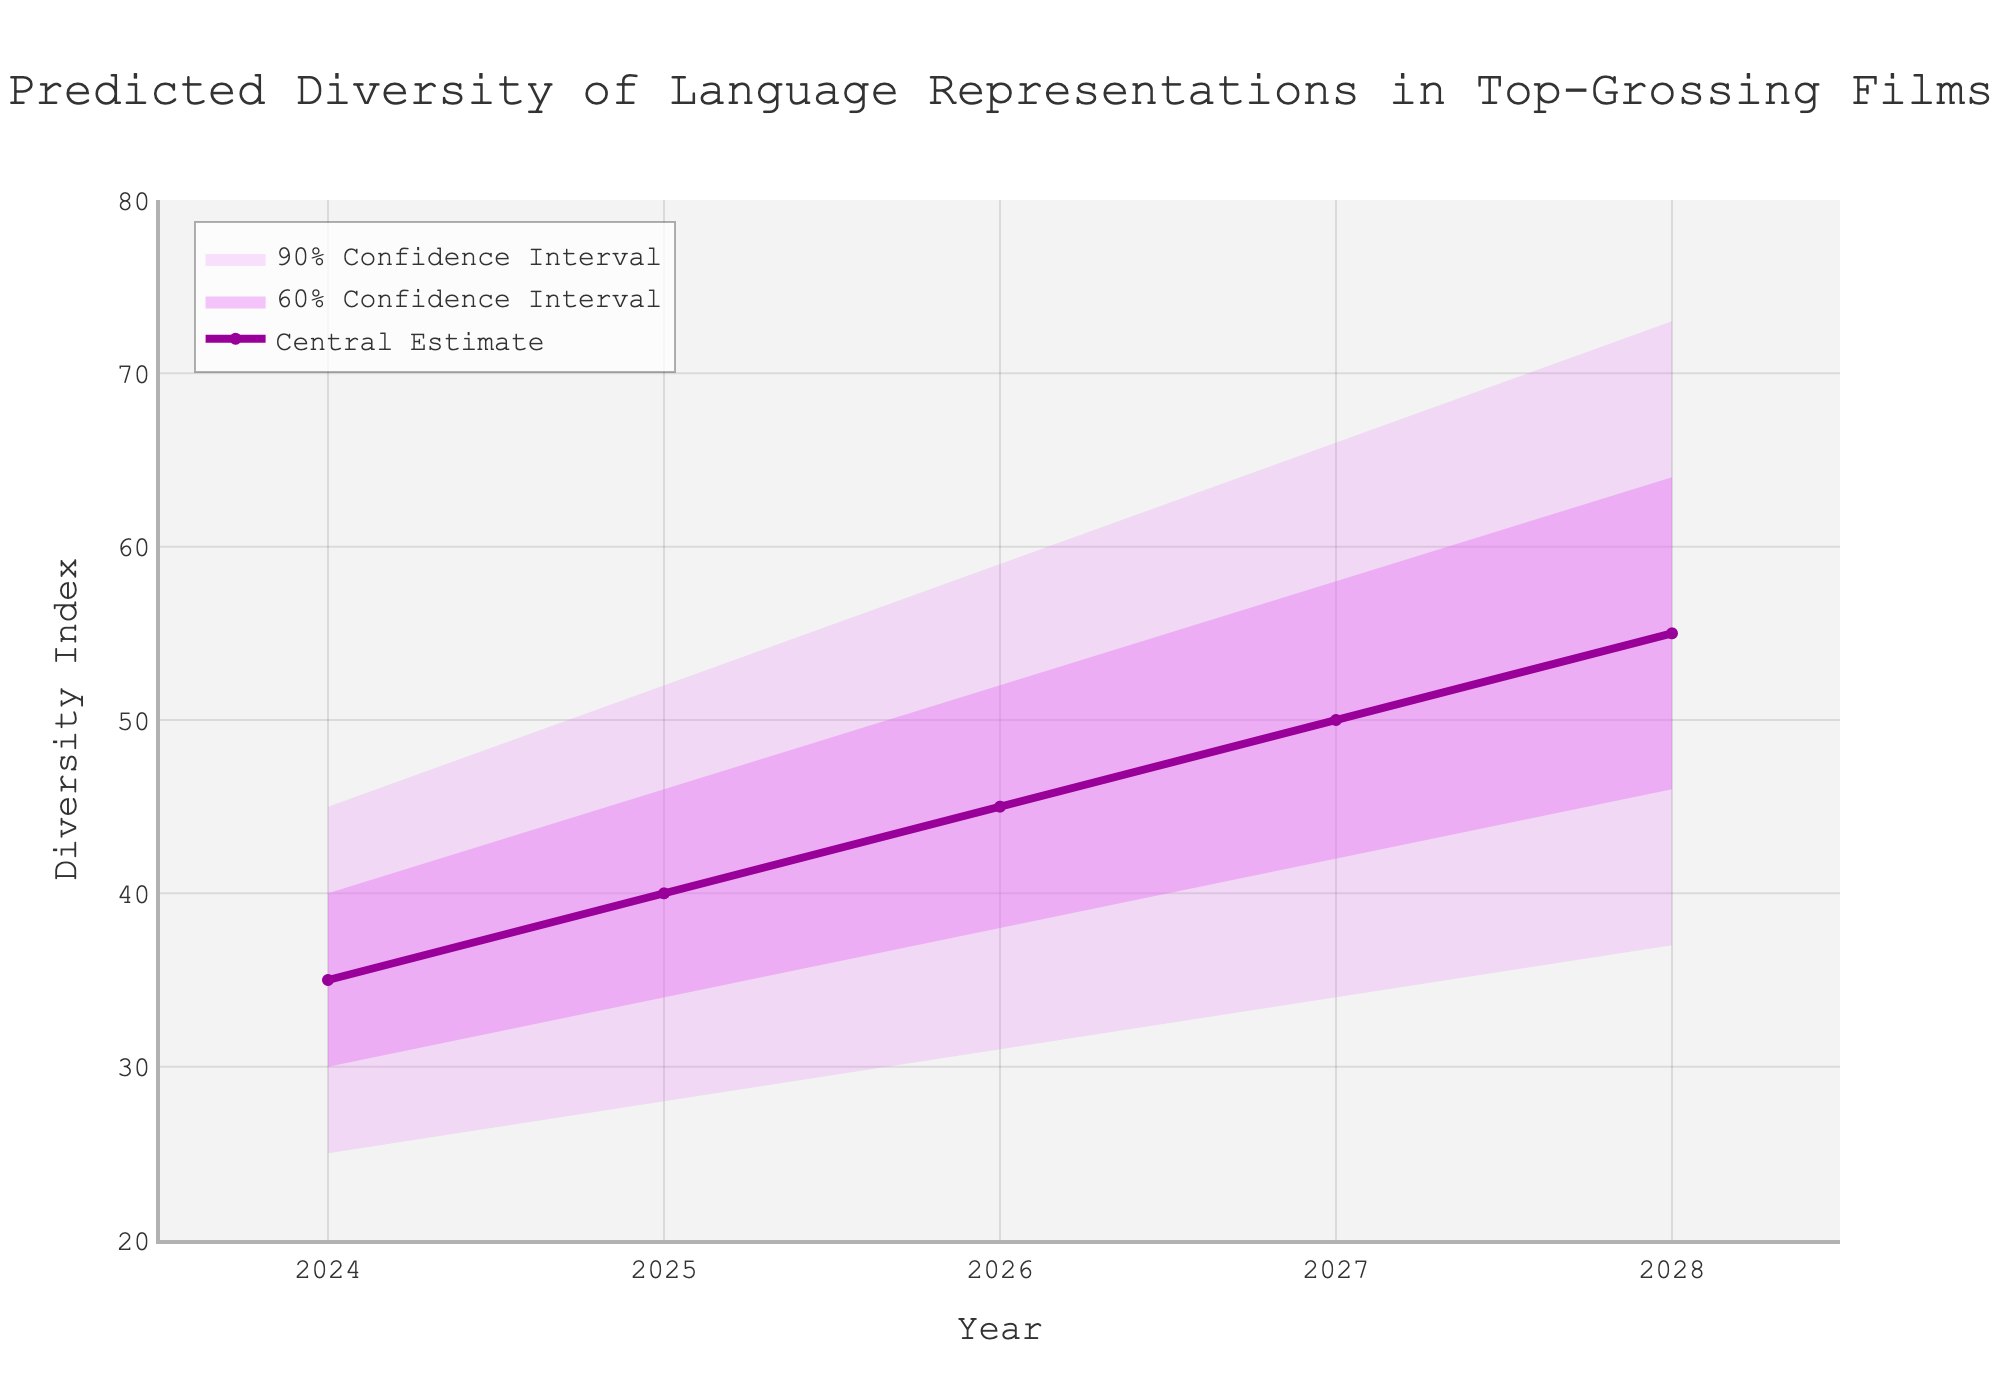What is the central estimate for the year 2025? Look at the central estimate line on the plot and find the value corresponding to the year 2025.
Answer: 40 What is the lower 10% confidence interval for the year 2026? Identify the lower bound of the shaded area representing the 10% confidence interval for the year 2026.
Answer: 31 How much does the central estimate increase from 2024 to 2028? Subtract the central estimate for 2024 from the central estimate for 2028: 55 - 35 = 20.
Answer: 20 By how much does the upper 90% confidence interval change from 2024 to 2027? Subtract the upper 90% confidence interval value for 2024 from the value for 2027: 66 - 45 = 21.
Answer: 21 What is the range between the lower 10% and upper 90% confidence intervals for 2025? Subtract the lower 10% confidence interval for 2025 from the upper 90% confidence interval for the same year: 52 - 28 = 24.
Answer: 24 Which year has the highest central estimate? Identify the year with the highest central estimate line value.
Answer: 2028 In which year does the lower 20% confidence interval reach 30? Find the year where the lower 20% confidence interval first reaches the value of 30.
Answer: 2024 What is the difference between the upper 80% confidence intervals for 2026 and 2028? Subtract the upper 80% value for 2026 from the value for 2028: 64 - 52 = 12.
Answer: 12 How does the range of the 60% confidence interval change from 2024 to 2028? Calculate the difference between the upper and lower 80% confidence intervals for both years and find the change: (64 - 46) - (40 - 30) = 18 - 10 = 8.
Answer: 8 